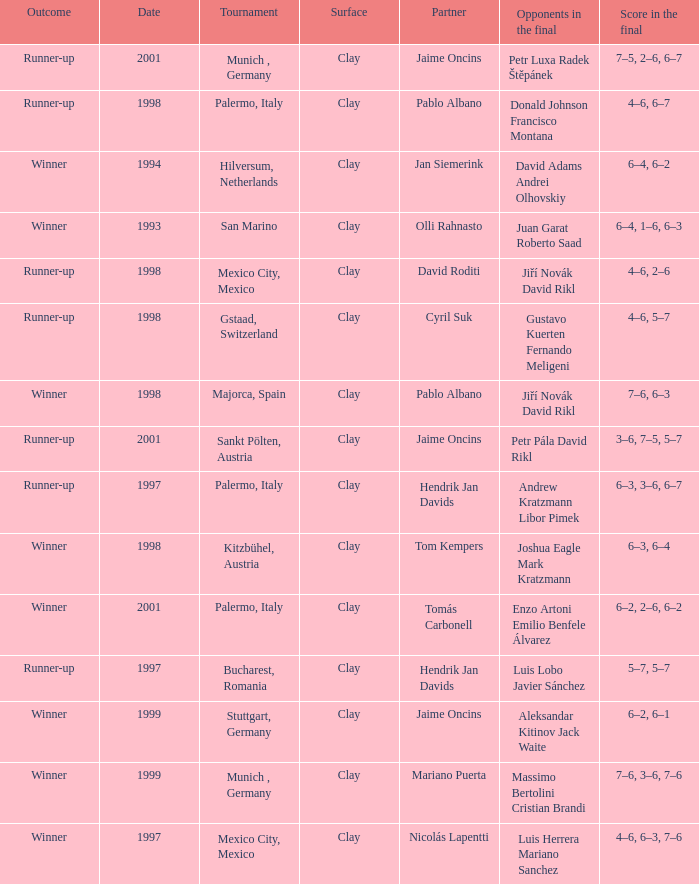Who are the Opponents in the final prior to 1998 in the Bucharest, Romania Tournament? Luis Lobo Javier Sánchez. 